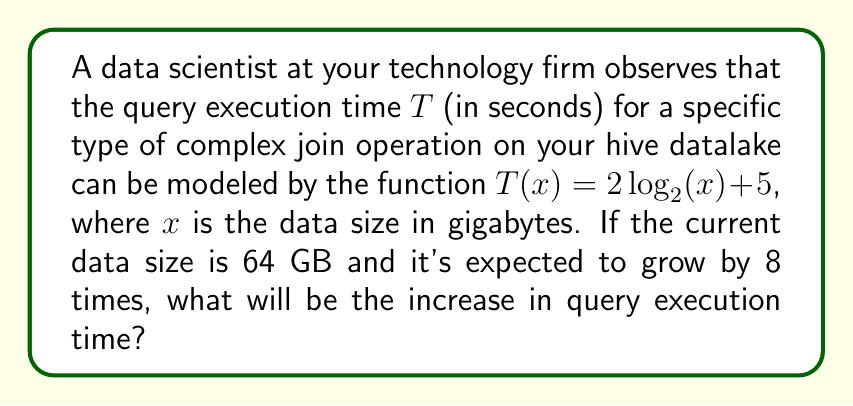Can you solve this math problem? Let's approach this step-by-step:

1) First, we need to calculate the current query execution time for 64 GB:
   $T(64) = 2\log_2(64) + 5$
   $= 2(6) + 5$ (since $2^6 = 64$)
   $= 12 + 5 = 17$ seconds

2) Next, we calculate the query execution time for the future data size (8 times current):
   Future size = $64 * 8 = 512$ GB
   $T(512) = 2\log_2(512) + 5$
   $= 2(9) + 5$ (since $2^9 = 512$)
   $= 18 + 5 = 23$ seconds

3) To find the increase in execution time, we subtract:
   Increase = $T(512) - T(64) = 23 - 17 = 6$ seconds

This result aligns with the logarithmic nature of the function, where an 8-fold increase in data size results in a constant increase in execution time, regardless of the starting size.
Answer: 6 seconds 